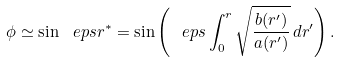Convert formula to latex. <formula><loc_0><loc_0><loc_500><loc_500>\phi \simeq \sin \ e p s r ^ { * } = \sin \left ( \ e p s \int _ { 0 } ^ { r } \sqrt { \frac { b ( r ^ { \prime } ) } { a ( r ^ { \prime } ) } } \, d r ^ { \prime } \right ) .</formula> 